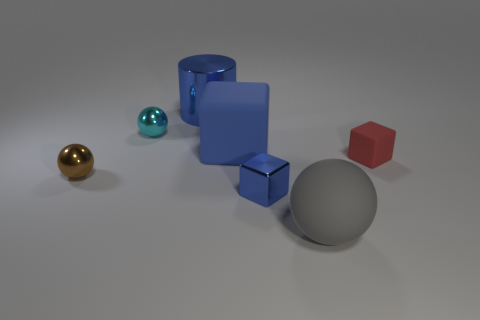What material is the tiny cyan thing that is the same shape as the brown thing?
Keep it short and to the point. Metal. How many brown shiny objects are in front of the large blue matte object?
Offer a very short reply. 1. There is a big thing that is the same color as the large block; what is its shape?
Provide a short and direct response. Cylinder. Are there any large gray matte objects that are in front of the blue metallic thing in front of the blue metal thing behind the tiny brown ball?
Your answer should be very brief. Yes. Is the cylinder the same size as the rubber sphere?
Ensure brevity in your answer.  Yes. Is the number of shiny things that are left of the blue rubber thing the same as the number of tiny brown balls behind the cyan object?
Your answer should be compact. No. There is a metal object that is on the right side of the big metal cylinder; what shape is it?
Give a very brief answer. Cube. What is the shape of the blue shiny thing that is the same size as the blue rubber object?
Your answer should be very brief. Cylinder. The tiny object to the right of the matte object in front of the tiny block that is to the right of the large gray sphere is what color?
Provide a short and direct response. Red. Does the tiny matte object have the same shape as the big blue rubber thing?
Your answer should be very brief. Yes. 